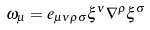Convert formula to latex. <formula><loc_0><loc_0><loc_500><loc_500>\omega _ { \mu } = e _ { \mu \nu \rho \sigma } \xi ^ { \nu } \nabla ^ { \rho } \xi ^ { \sigma }</formula> 